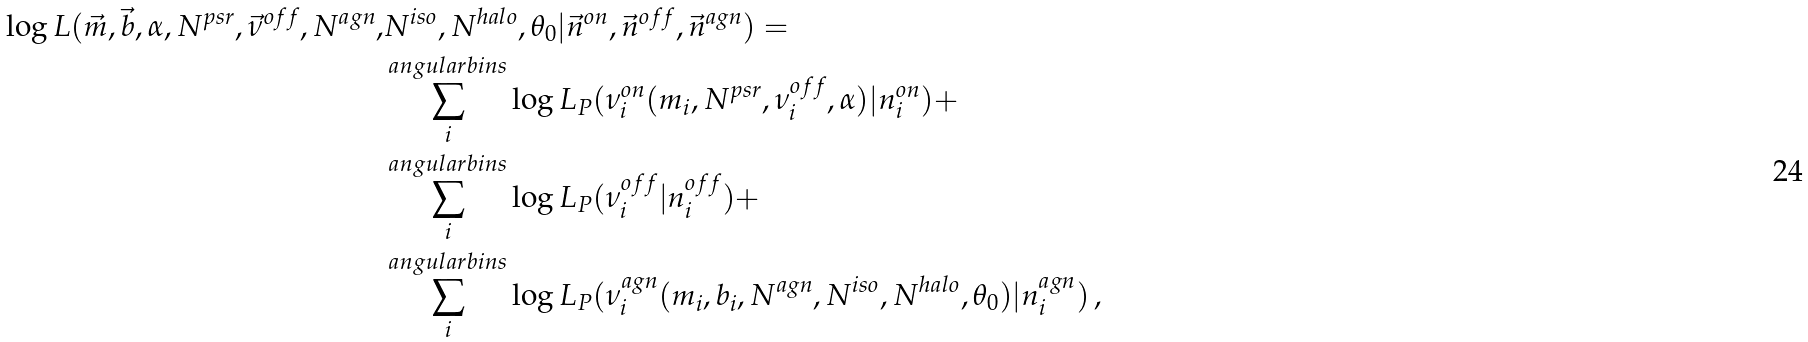<formula> <loc_0><loc_0><loc_500><loc_500>\log L ( \vec { m } , \vec { b } , \alpha , N ^ { p s r } , \vec { \nu } ^ { o f f } , N ^ { a g n } , & N ^ { i s o } , N ^ { h a l o } , \theta _ { 0 } | \vec { n } ^ { o n } , \vec { n } ^ { o f f } , \vec { n } ^ { a g n } ) = \\ & \sum ^ { a n g u l a r b i n s } _ { i } \log L _ { P } ( { \nu } ^ { o n } _ { i } ( m _ { i } , N ^ { p s r } , \nu ^ { o f f } _ { i } , \alpha ) | n ^ { o n } _ { i } ) + \\ & \sum ^ { a n g u l a r b i n s } _ { i } \log L _ { P } ( \nu ^ { o f f } _ { i } | n ^ { o f f } _ { i } ) + \\ & \sum ^ { a n g u l a r b i n s } _ { i } \log L _ { P } ( \nu ^ { a g n } _ { i } ( m _ { i } , b _ { i } , N ^ { a g n } , N ^ { i s o } , N ^ { h a l o } , \theta _ { 0 } ) | n ^ { a g n } _ { i } ) \, ,</formula> 